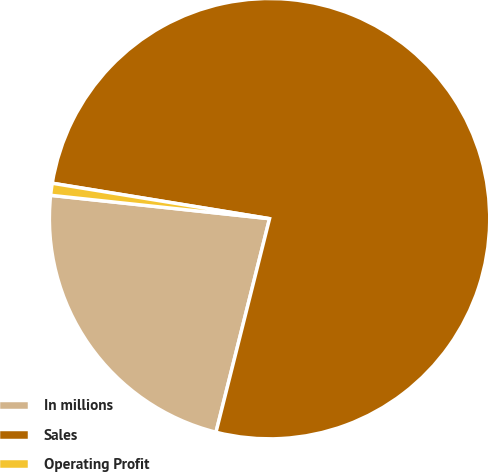<chart> <loc_0><loc_0><loc_500><loc_500><pie_chart><fcel>In millions<fcel>Sales<fcel>Operating Profit<nl><fcel>22.78%<fcel>76.33%<fcel>0.88%<nl></chart> 